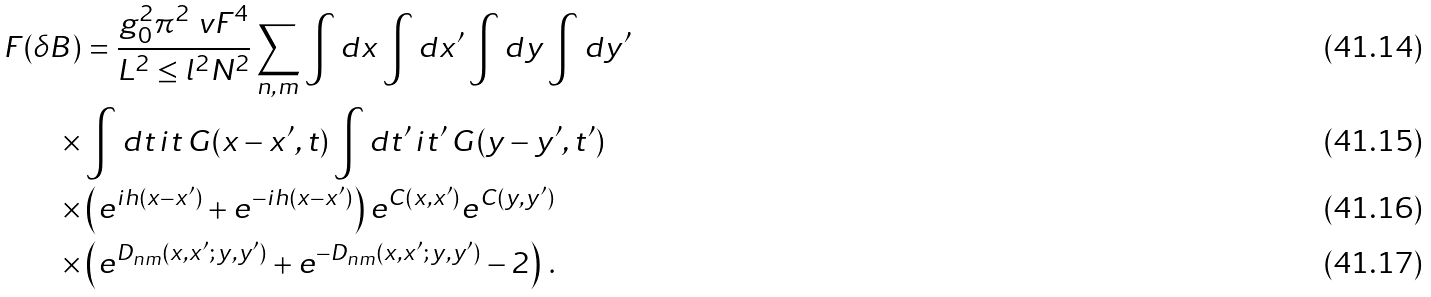Convert formula to latex. <formula><loc_0><loc_0><loc_500><loc_500>F ( \delta B ) & = \frac { g _ { 0 } ^ { 2 } \pi ^ { 2 } \ v F ^ { 4 } } { L ^ { 2 } \leq l ^ { 2 } N ^ { 2 } } \sum _ { n , m } \int d x \int d x ^ { \prime } \int d y \int d y ^ { \prime } \\ \times & \int d t \, i t \, G ( x - x ^ { \prime } , t ) \int d t ^ { \prime } \, i t ^ { \prime } \, G ( y - y ^ { \prime } , t ^ { \prime } ) \\ \times & \left ( e ^ { i h ( x - x ^ { \prime } ) } + e ^ { - i h ( x - x ^ { \prime } ) } \right ) e ^ { C ( x , x ^ { \prime } ) } e ^ { C ( y , y ^ { \prime } ) } \\ \times & \left ( e ^ { D _ { n m } ( x , x ^ { \prime } ; \, y , y ^ { \prime } ) } + e ^ { - D _ { n m } ( x , x ^ { \prime } ; \, y , y ^ { \prime } ) } - 2 \right ) \, .</formula> 